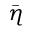<formula> <loc_0><loc_0><loc_500><loc_500>\bar { \eta }</formula> 